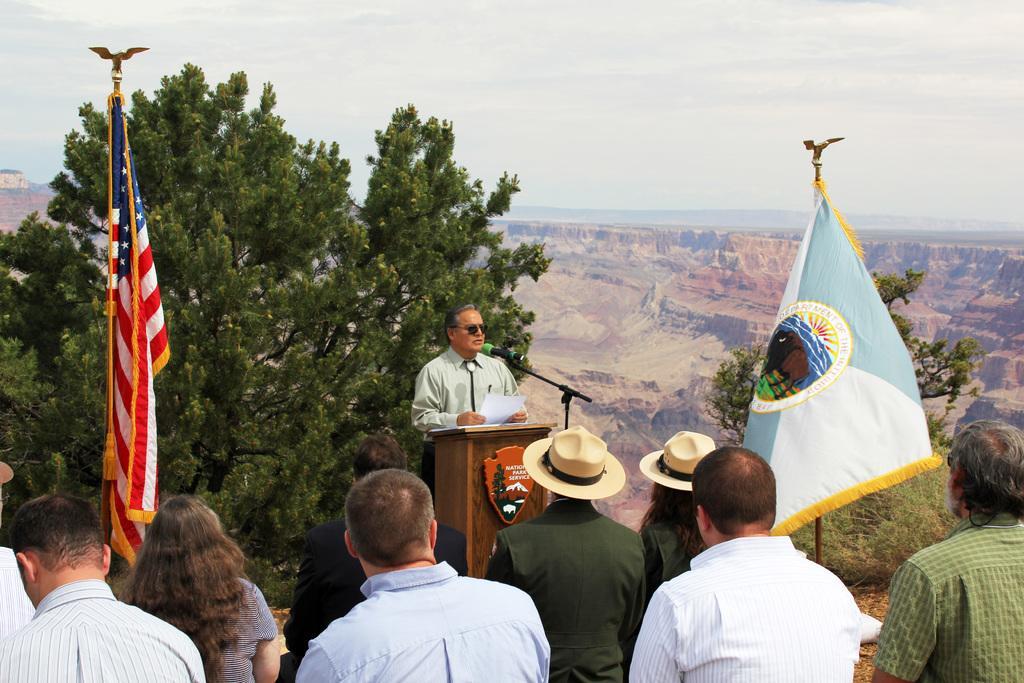Could you give a brief overview of what you see in this image? In this image there is a person standing in front of the table. On the table there is a mike and the person holding a paper in his hand, in front of him there are few other people standing and there are two flags. In the background there are trees, mountains and the sky. 